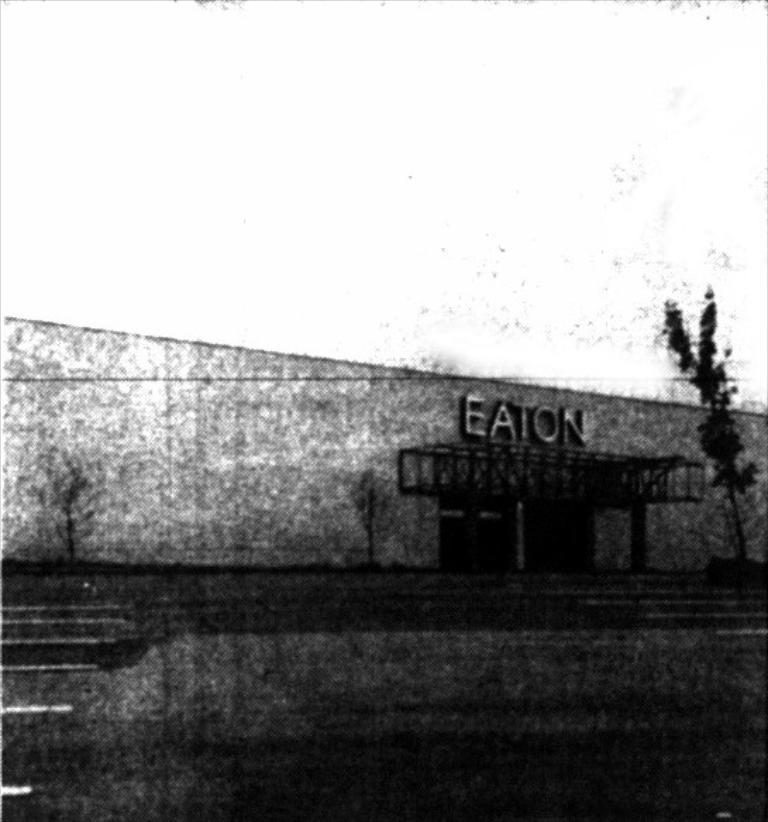<image>
Provide a brief description of the given image. Crackly, damaged and fuzzy its hard to tell if this is Eaton station pictured or some other industrial unit. 